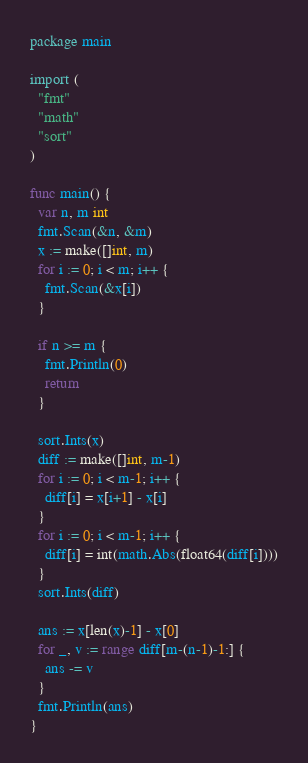<code> <loc_0><loc_0><loc_500><loc_500><_Go_>package main

import (
  "fmt"
  "math"
  "sort"
)

func main() {
  var n, m int
  fmt.Scan(&n, &m)
  x := make([]int, m)
  for i := 0; i < m; i++ {
    fmt.Scan(&x[i])
  }

  if n >= m {
    fmt.Println(0)
    return
  }

  sort.Ints(x)
  diff := make([]int, m-1)
  for i := 0; i < m-1; i++ {
    diff[i] = x[i+1] - x[i]
  }
  for i := 0; i < m-1; i++ {
    diff[i] = int(math.Abs(float64(diff[i])))
  }
  sort.Ints(diff)

  ans := x[len(x)-1] - x[0]
  for _, v := range diff[m-(n-1)-1:] {
    ans -= v
  }
  fmt.Println(ans)
}</code> 